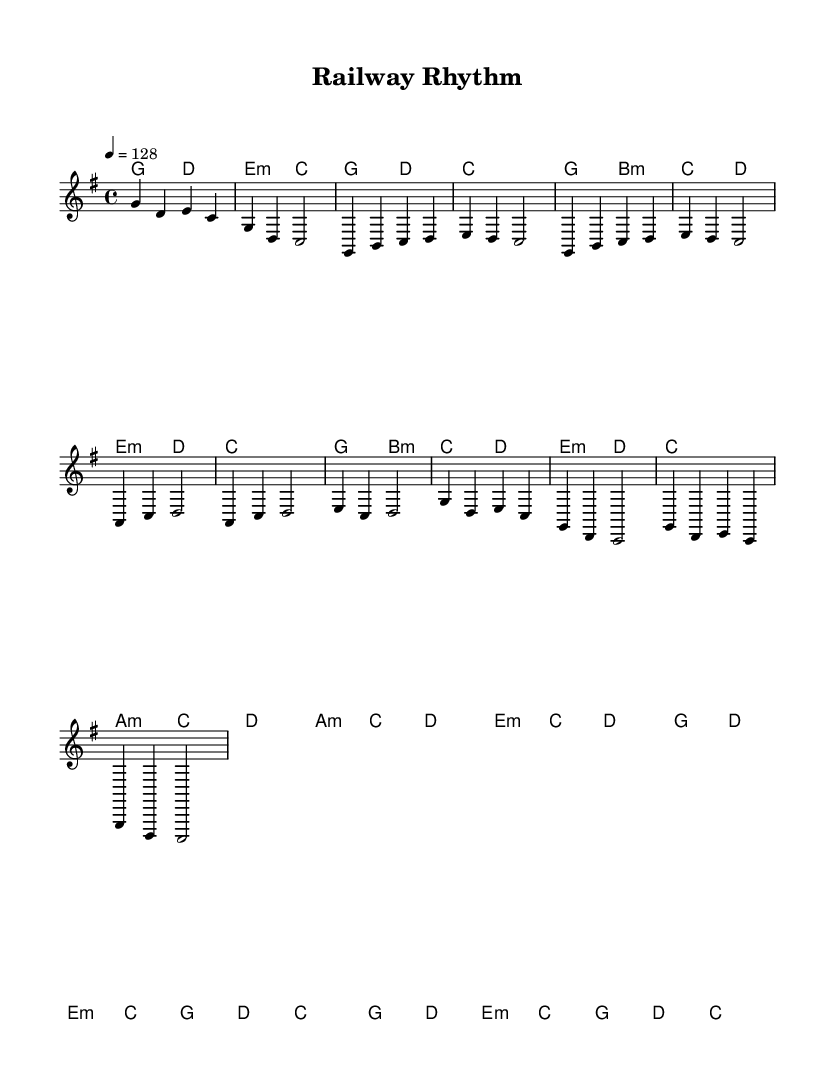What is the key signature of this music? The key signature is G major, which has one sharp (F#). This can be identified by looking at the beginning of the sheet music, where the G major key signature is indicated.
Answer: G major What is the time signature of this piece? The time signature is 4/4, which means there are four beats in each measure and a quarter note receives one beat. This is shown prominently at the start of the score.
Answer: 4/4 What is the tempo marking? The tempo marking is 128 beats per minute, indicated by the tempo instruction at the beginning of the piece. This specifies the speed at which the piece should be played.
Answer: 128 How many measures are in the Chorus section? The Chorus section contains four measures. By counting the measures in the scored Chorus after the Pre-Chorus, we see that it spans from the start of the final part through to its conclusion.
Answer: 4 What type of chords are used in the Pre-Chorus? The Pre-Chorus features minor chords, specifically starting with A minor and E minor chords. This can be deduced from observing the chord symbols above the notation in the Pre-Chorus section.
Answer: Minor Which instrument is likely performing the melody? The staff labeled "melody" suggests that this part is performed by a melody-instrument such as a keyboard or a lead vocal. It is common in pop music for the melody to be sung or played on such instruments.
Answer: Melody instrument What is the last chord in the piece? The last chord is a C major chord, which is indicated on the last measure of the harmonies. It resolves the piece by providing a sense of closure.
Answer: C major 